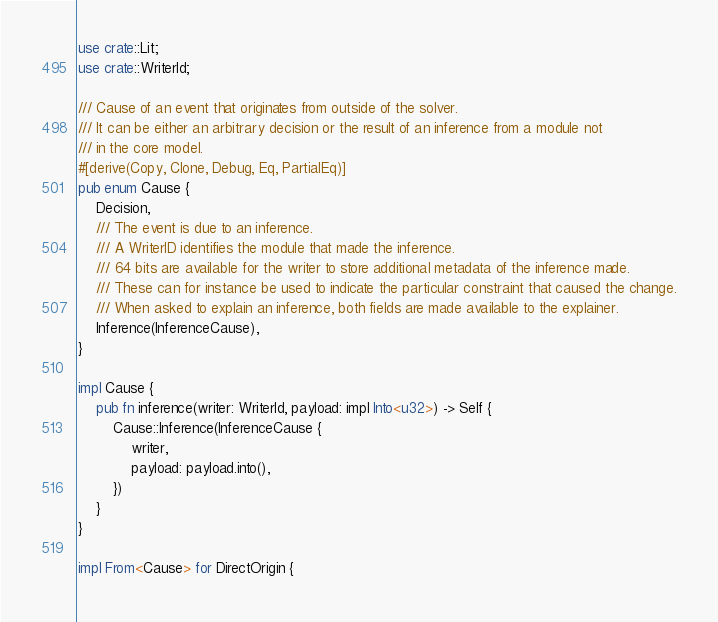<code> <loc_0><loc_0><loc_500><loc_500><_Rust_>use crate::Lit;
use crate::WriterId;

/// Cause of an event that originates from outside of the solver.
/// It can be either an arbitrary decision or the result of an inference from a module not
/// in the core model.
#[derive(Copy, Clone, Debug, Eq, PartialEq)]
pub enum Cause {
    Decision,
    /// The event is due to an inference.
    /// A WriterID identifies the module that made the inference.
    /// 64 bits are available for the writer to store additional metadata of the inference made.
    /// These can for instance be used to indicate the particular constraint that caused the change.
    /// When asked to explain an inference, both fields are made available to the explainer.
    Inference(InferenceCause),
}

impl Cause {
    pub fn inference(writer: WriterId, payload: impl Into<u32>) -> Self {
        Cause::Inference(InferenceCause {
            writer,
            payload: payload.into(),
        })
    }
}

impl From<Cause> for DirectOrigin {</code> 